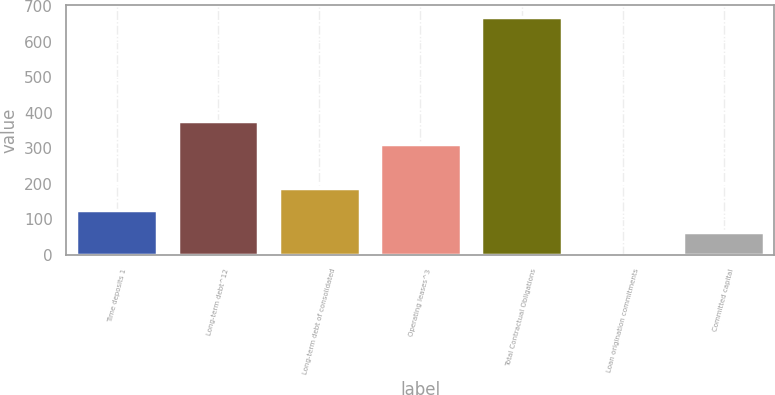<chart> <loc_0><loc_0><loc_500><loc_500><bar_chart><fcel>Time deposits 1<fcel>Long-term debt^12<fcel>Long-term debt of consolidated<fcel>Operating leases^3<fcel>Total Contractual Obligations<fcel>Loan origination commitments<fcel>Committed capital<nl><fcel>125.78<fcel>376.2<fcel>188.32<fcel>313.4<fcel>670.74<fcel>0.7<fcel>63.24<nl></chart> 